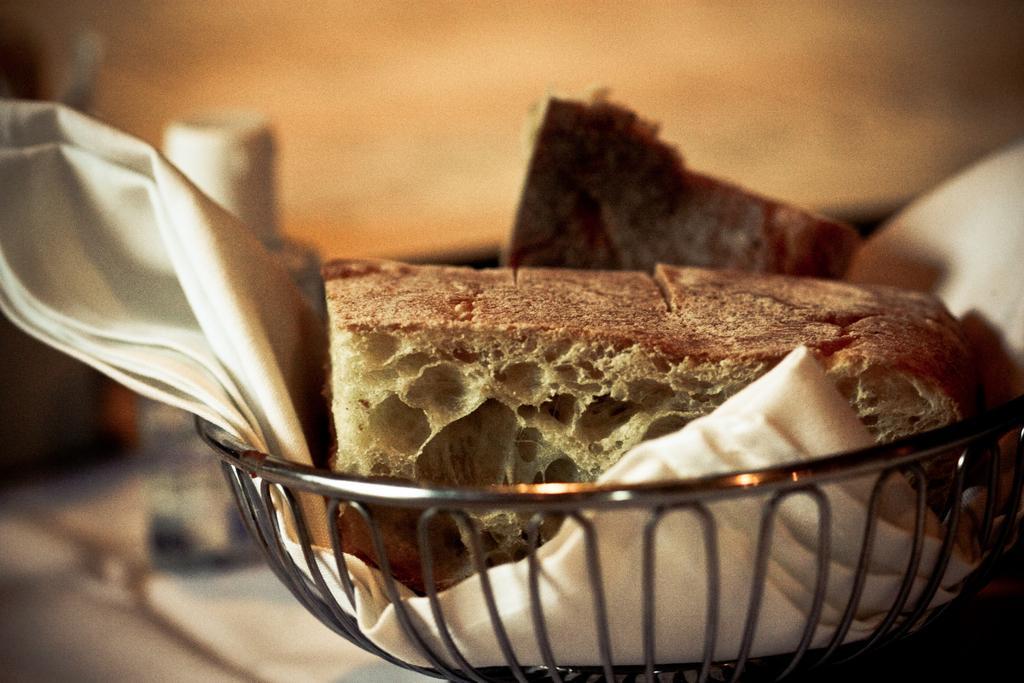How would you summarize this image in a sentence or two? In this picture we can see bowl with food and cloth. In the background of the image it is blurry. 